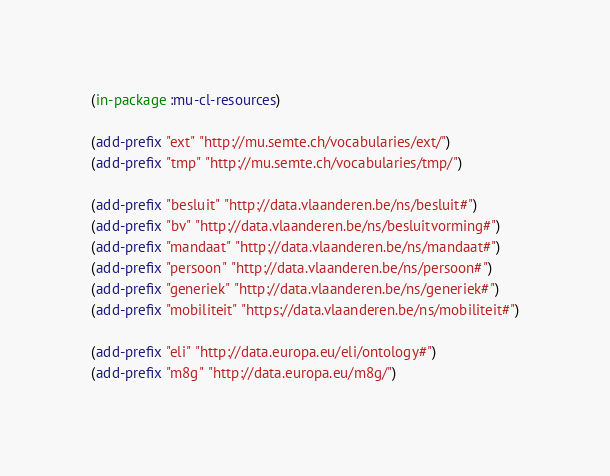Convert code to text. <code><loc_0><loc_0><loc_500><loc_500><_Lisp_>(in-package :mu-cl-resources)

(add-prefix "ext" "http://mu.semte.ch/vocabularies/ext/")
(add-prefix "tmp" "http://mu.semte.ch/vocabularies/tmp/")

(add-prefix "besluit" "http://data.vlaanderen.be/ns/besluit#")
(add-prefix "bv" "http://data.vlaanderen.be/ns/besluitvorming#")
(add-prefix "mandaat" "http://data.vlaanderen.be/ns/mandaat#")
(add-prefix "persoon" "http://data.vlaanderen.be/ns/persoon#")
(add-prefix "generiek" "http://data.vlaanderen.be/ns/generiek#")
(add-prefix "mobiliteit" "https://data.vlaanderen.be/ns/mobiliteit#")

(add-prefix "eli" "http://data.europa.eu/eli/ontology#")
(add-prefix "m8g" "http://data.europa.eu/m8g/")</code> 